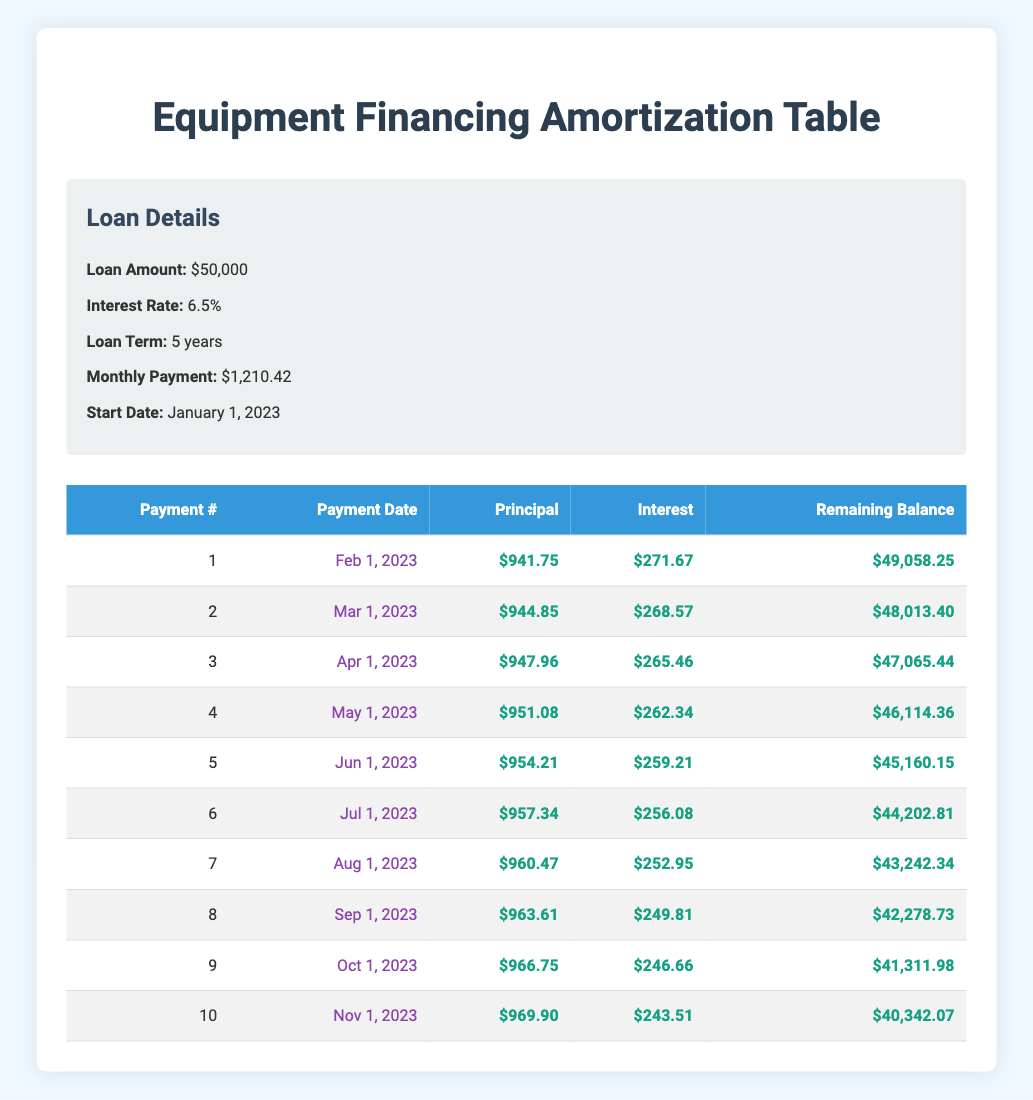What is the total amount paid in principal after the first two payments? The principal payments for the first two payments are $941.75 (Payment 1) and $944.85 (Payment 2). Adding these gives 941.75 + 944.85 = 1886.60
Answer: 1886.60 How much interest is paid in the first payment? The interest payment for the first payment is listed in the table as $271.67.
Answer: 271.67 What is the remaining balance after the 5th payment? The remaining balance after the 5th payment is recorded in the table as $45,160.15.
Answer: 45,160.15 Is the interest payment in the 10th payment lower than the interest payment in the 1st payment? Yes, the interest payment for the 10th payment is $243.51 which is lower than the first payment's interest of $271.67.
Answer: Yes What is the total amount paid towards interest in the first three payments? The interest payments for the first three payments are $271.67 (Payment 1), $268.57 (Payment 2), and $265.46 (Payment 3). Adding these gives 271.67 + 268.57 + 265.46 = 805.70
Answer: 805.70 What date is the 7th payment scheduled for? The 7th payment is scheduled for August 1, 2023, as seen in the table under the Payment Date column.
Answer: August 1, 2023 How much total principal is paid in the first half of the loan term? The total principal paid in the first half (the first 5 payments) can be calculated by adding the first five principal payments: 941.75 + 944.85 + 947.96 + 951.08 + 954.21 = 4,739.85
Answer: 4,739.85 Is the monthly payment constant throughout the loan term? Yes, the monthly payment of $1,210.42 remains constant as indicated in the loan details.
Answer: Yes 